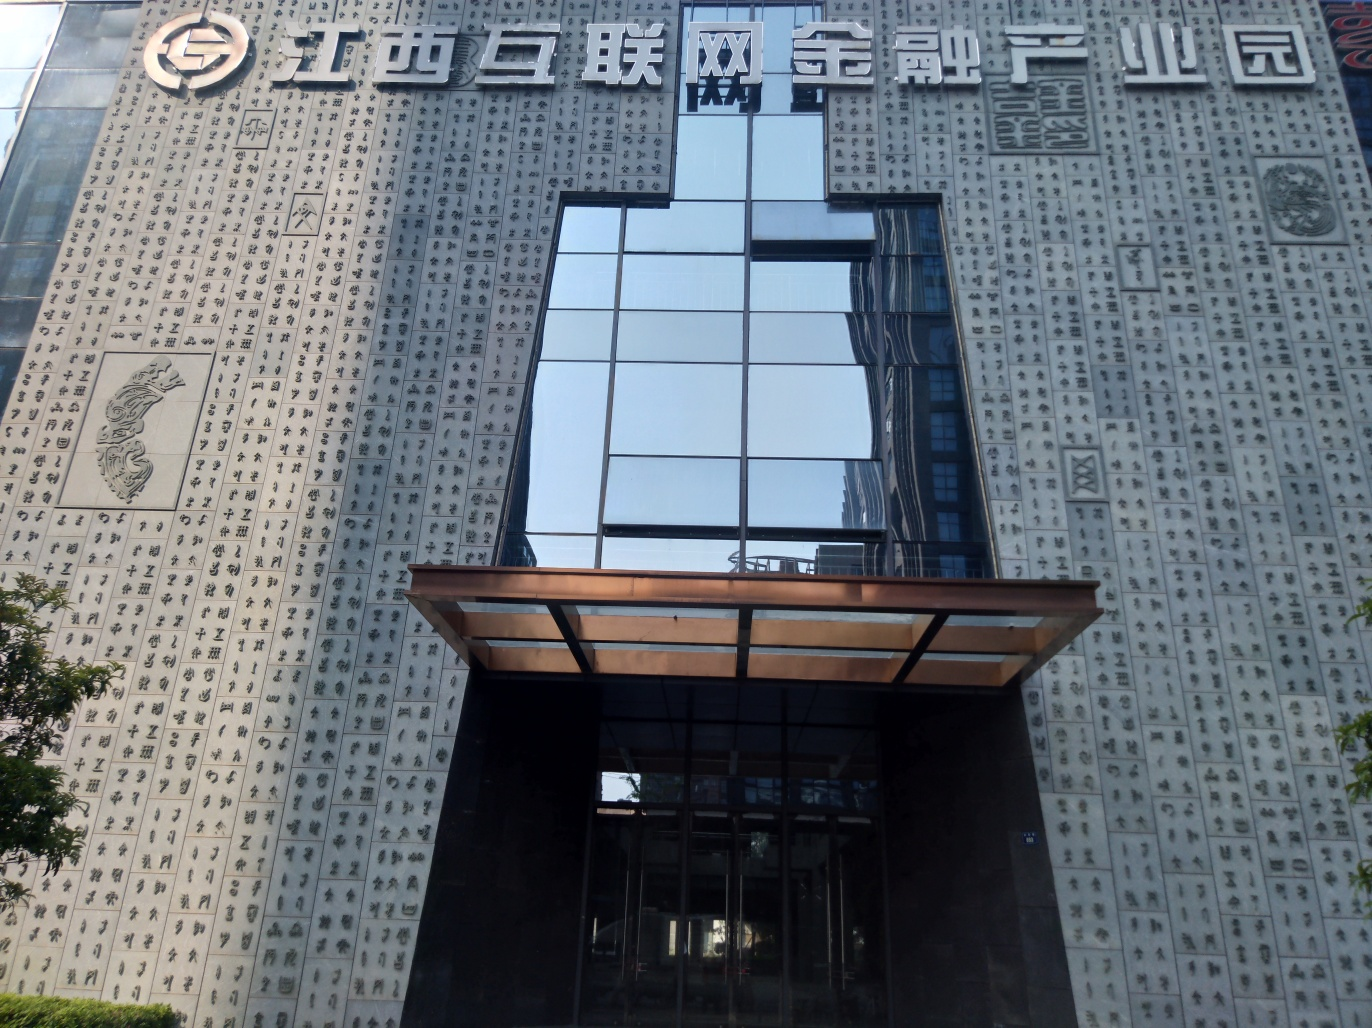How does the architecture of the glass section contrast with the rest of the building? The sleek, modern glass design creates a stark contrast against the densely character-covered exterior, perhaps symbolizing a bridge between contemporary aspirations and traditional foundations. Does the architecture of the building suggest anything about its function or the type of activities that might occur inside? The combination of traditional elements with modern design could imply a multifunctional space, likely a cultural or business center aiming to preserve heritage while embracing modernity. 